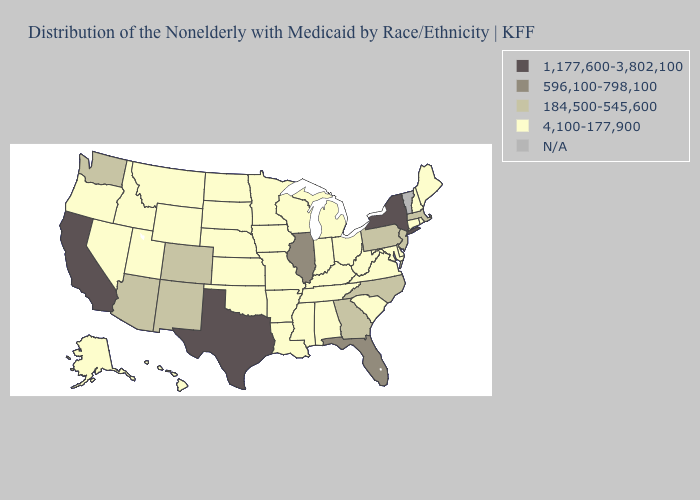Does California have the lowest value in the West?
Quick response, please. No. Among the states that border Rhode Island , which have the highest value?
Answer briefly. Massachusetts. Does Nebraska have the lowest value in the MidWest?
Write a very short answer. Yes. Is the legend a continuous bar?
Concise answer only. No. What is the value of Michigan?
Answer briefly. 4,100-177,900. What is the value of Maine?
Keep it brief. 4,100-177,900. What is the value of North Dakota?
Answer briefly. 4,100-177,900. What is the highest value in the MidWest ?
Write a very short answer. 596,100-798,100. What is the highest value in the MidWest ?
Concise answer only. 596,100-798,100. What is the lowest value in the USA?
Write a very short answer. 4,100-177,900. Among the states that border Tennessee , does Arkansas have the lowest value?
Concise answer only. Yes. Does Texas have the highest value in the South?
Quick response, please. Yes. What is the value of Alaska?
Concise answer only. 4,100-177,900. 